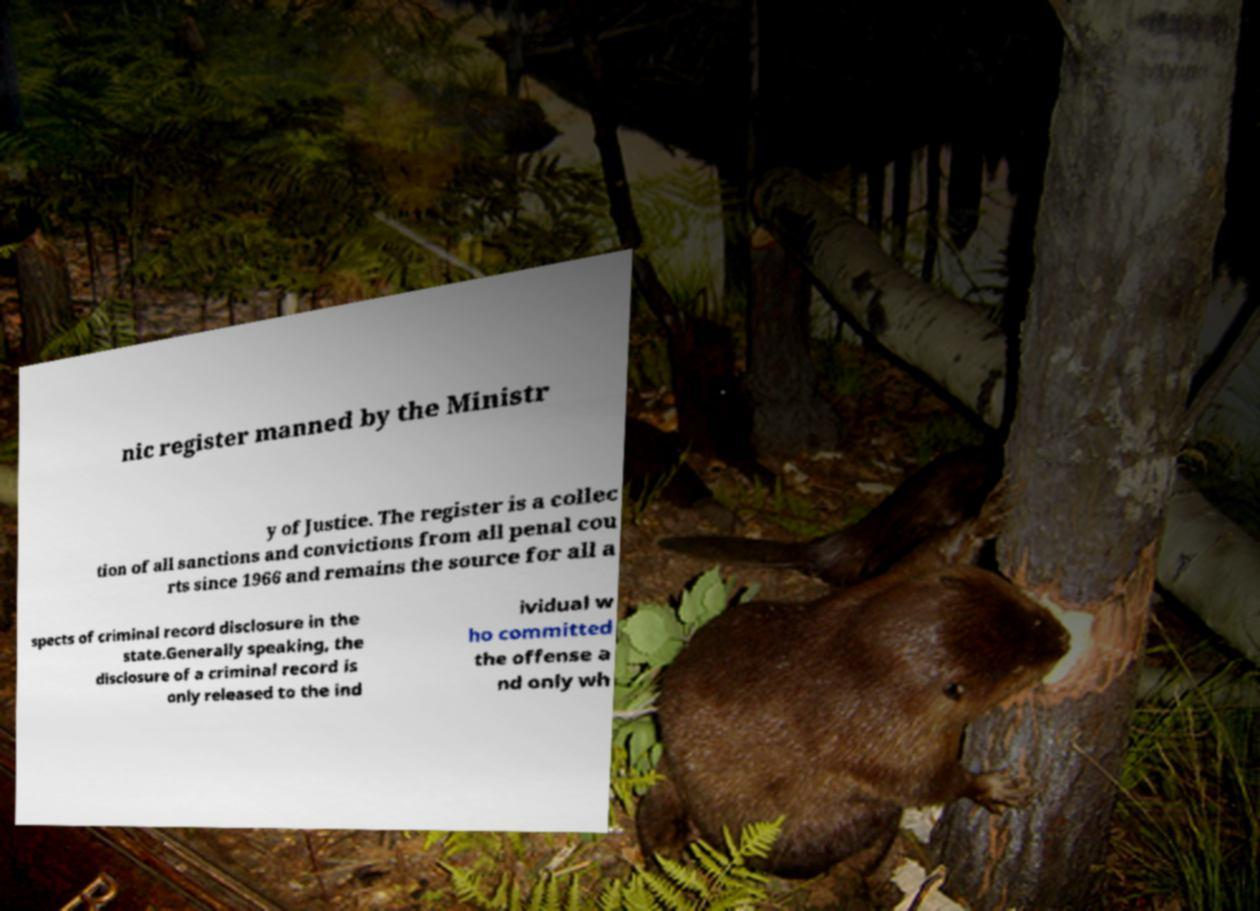Could you extract and type out the text from this image? nic register manned by the Ministr y of Justice. The register is a collec tion of all sanctions and convictions from all penal cou rts since 1966 and remains the source for all a spects of criminal record disclosure in the state.Generally speaking, the disclosure of a criminal record is only released to the ind ividual w ho committed the offense a nd only wh 